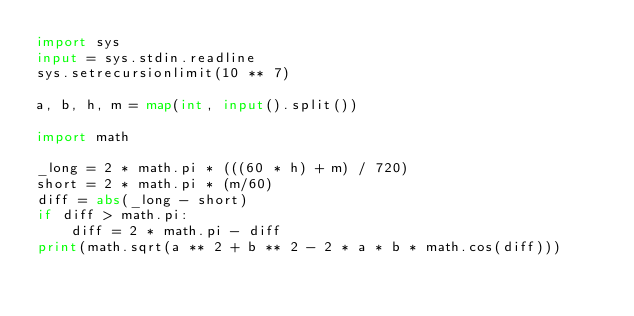<code> <loc_0><loc_0><loc_500><loc_500><_Python_>import sys
input = sys.stdin.readline
sys.setrecursionlimit(10 ** 7)

a, b, h, m = map(int, input().split())

import math

_long = 2 * math.pi * (((60 * h) + m) / 720)
short = 2 * math.pi * (m/60)
diff = abs(_long - short)
if diff > math.pi:
    diff = 2 * math.pi - diff
print(math.sqrt(a ** 2 + b ** 2 - 2 * a * b * math.cos(diff)))
</code> 